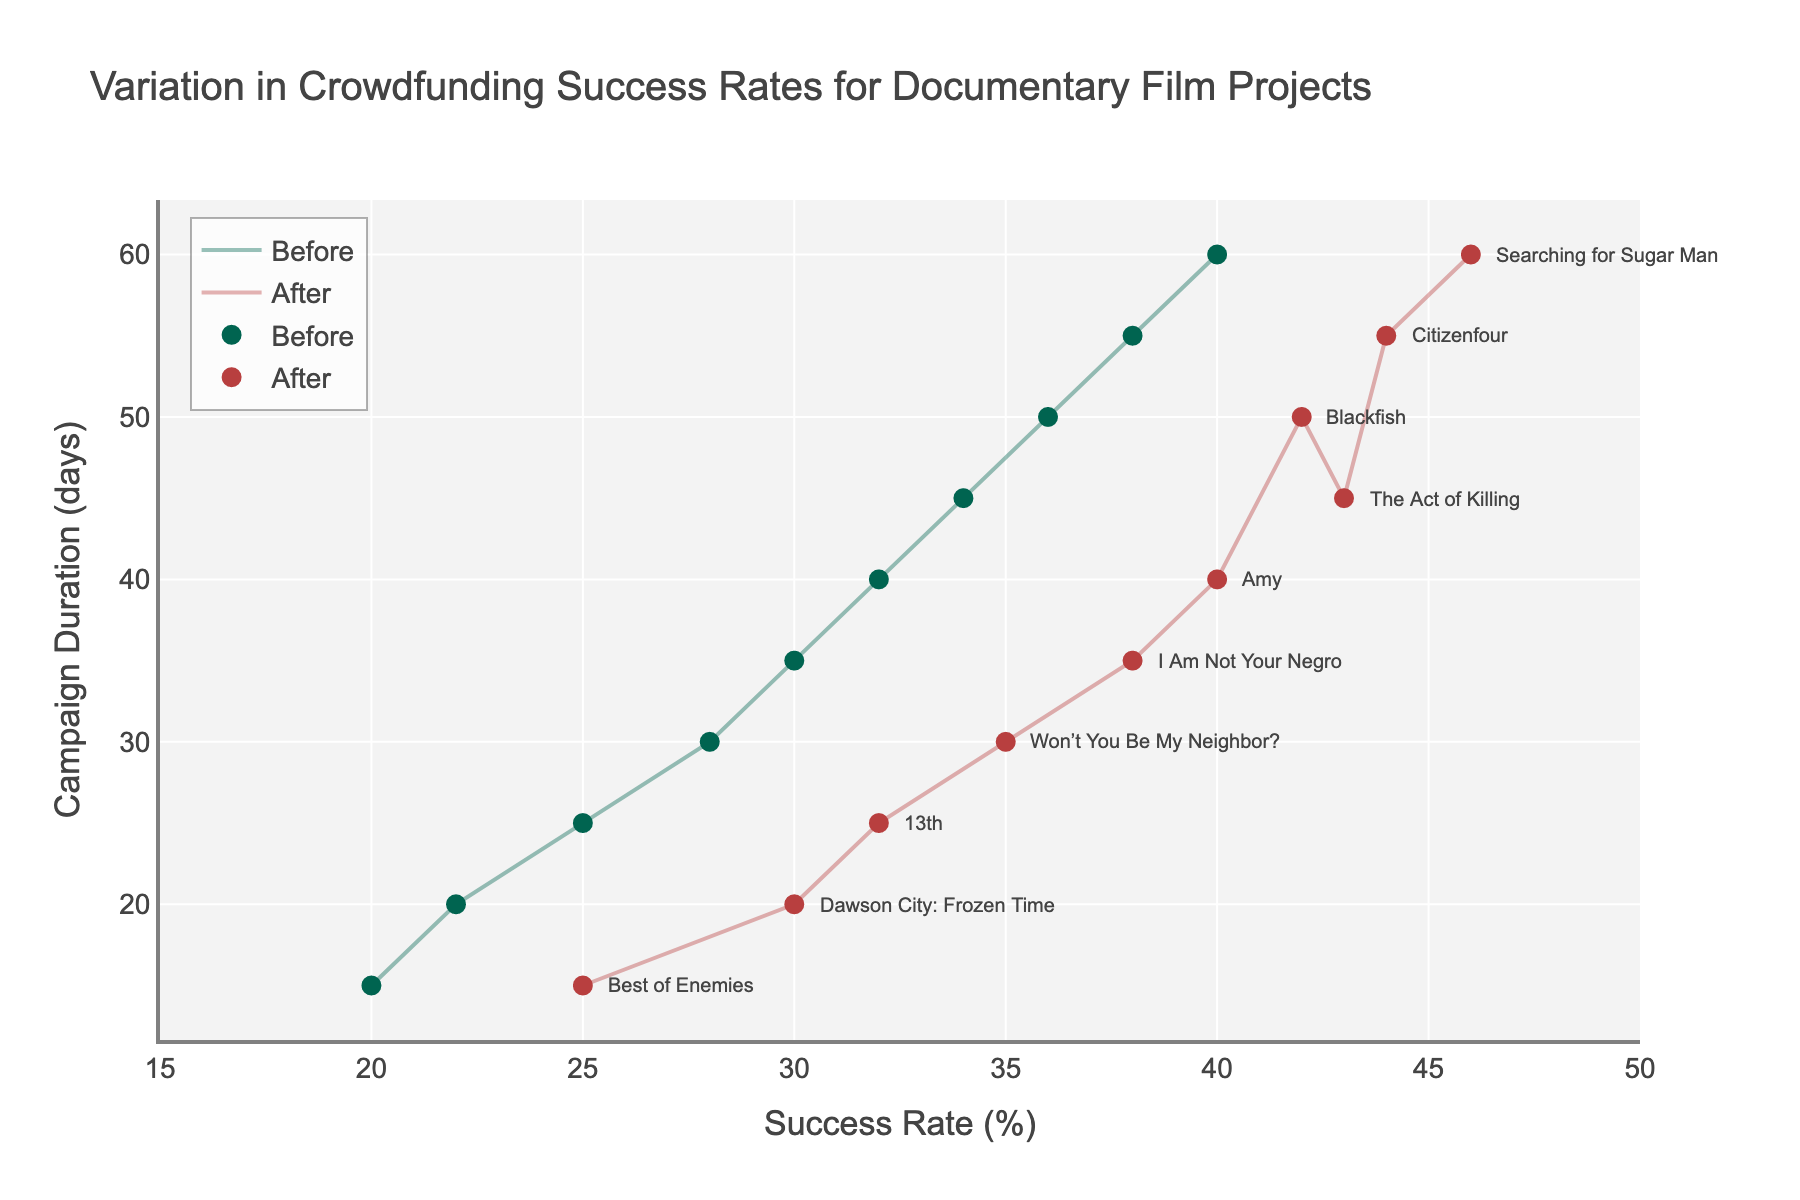what is the title of the plot? The title is written at the top of the plot.
Answer: Variation in Crowdfunding Success Rates for Documentary Film Projects what is the unit of the x-axis? The label of the x-axis indicates the unit.
Answer: Success Rate (%) what color represents the "Success Rate Before" markers? The color used for these markers is visible in the plot's legend and on the plot itself.
Answer: Green what is the success rate after a 60-day campaign duration? Locate the marker for a 60-day campaign on the horizontal axis, then read its corresponding success rate value.
Answer: 46% what is the difference in success rates before and after a 30-day campaign? Subtract the "before" success rate from the "after" success rate for the 30-day campaign, 35 - 28.
Answer: 7% which campaign duration shows the smallest increase in success rate? Compare the differences between before and after success rates for each campaign; the smallest difference is between 15 and 25 (5%).
Answer: 15 days how many campaigns showed an increased success rate after the change? Count the number of campaigns where the after success rate is higher than the before success rate.
Answer: 10 what is the campaign duration of the documentary "13th"? Locate the annotation for "13th" to find its position on the y-axis, which indicates the campaign duration.
Answer: 25 days which documentary had the highest success rate before the change? Compare the "before" success rates for all documentaries and find the highest.
Answer: Searching for Sugar Man how many days is the difference between the campaign duration of "The Act of Killing" and "Dawson City: Frozen Time"? Subtract the campaign duration of "Dawson City: Frozen Time" from that of "The Act of Killing".
Answer: 25 days 